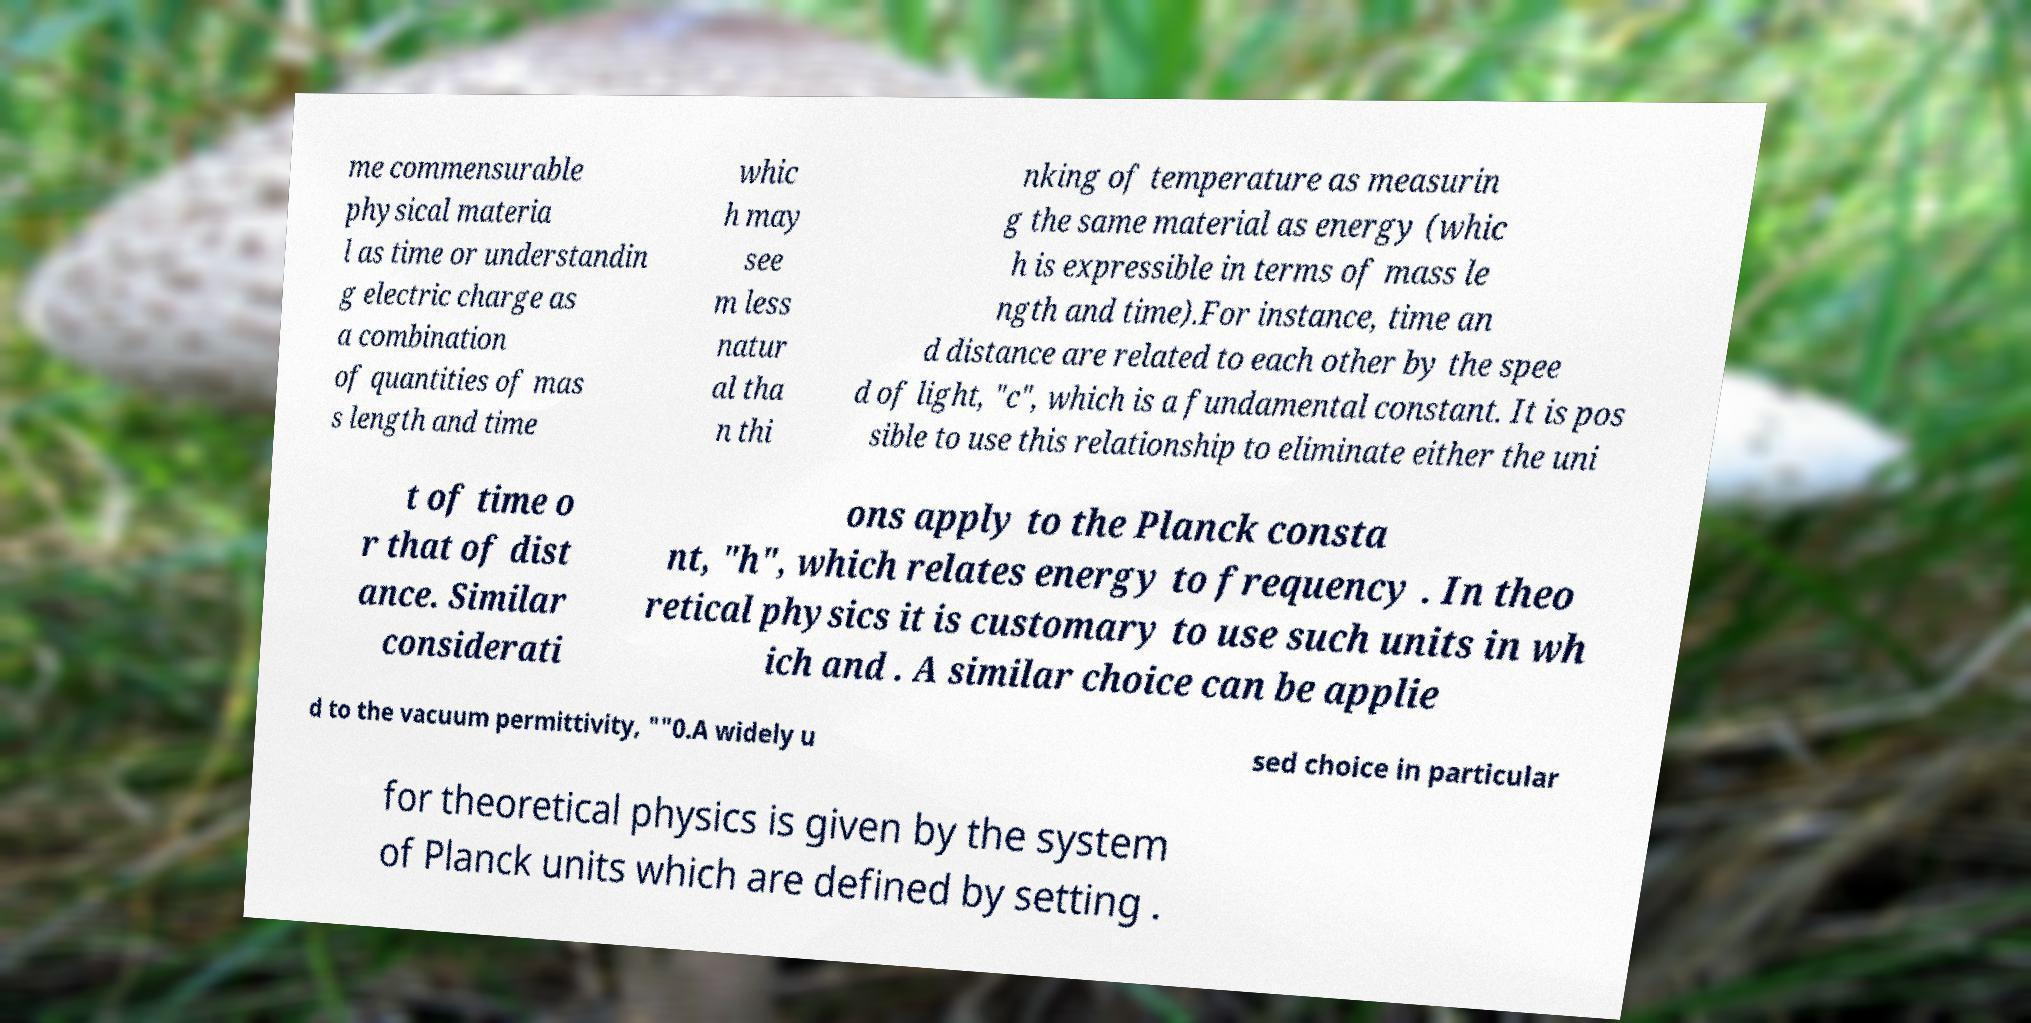Can you accurately transcribe the text from the provided image for me? me commensurable physical materia l as time or understandin g electric charge as a combination of quantities of mas s length and time whic h may see m less natur al tha n thi nking of temperature as measurin g the same material as energy (whic h is expressible in terms of mass le ngth and time).For instance, time an d distance are related to each other by the spee d of light, "c", which is a fundamental constant. It is pos sible to use this relationship to eliminate either the uni t of time o r that of dist ance. Similar considerati ons apply to the Planck consta nt, "h", which relates energy to frequency . In theo retical physics it is customary to use such units in wh ich and . A similar choice can be applie d to the vacuum permittivity, ""0.A widely u sed choice in particular for theoretical physics is given by the system of Planck units which are defined by setting . 